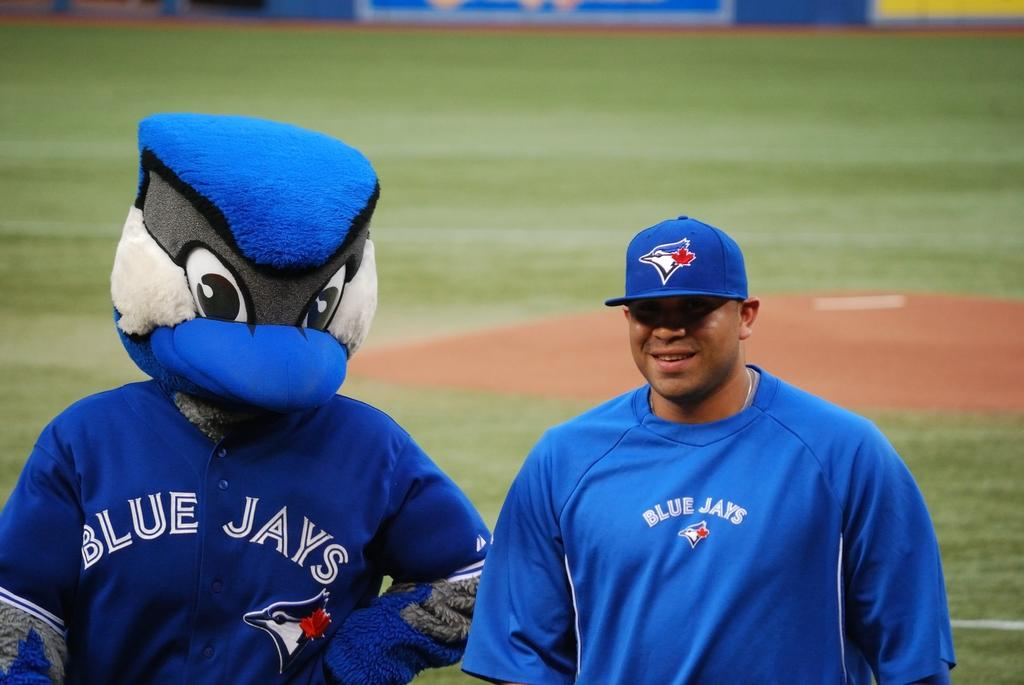Provide a one-sentence caption for the provided image. A man standing next to the blue jays mascot. 